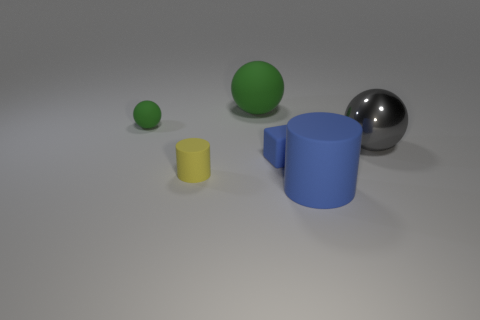How would you compare the textures of the objects presented? The objects appear to have different levels of shininess, indicating variations in texture. The yellow cylinder and green sphere have a matte finish, suggesting a rubber-like texture. The blue cylinder looks slightly glossier than the first two but still has a matte quality. The gray sphere, however, has a reflective surface, indicating a smooth and possibly metallic texture. 